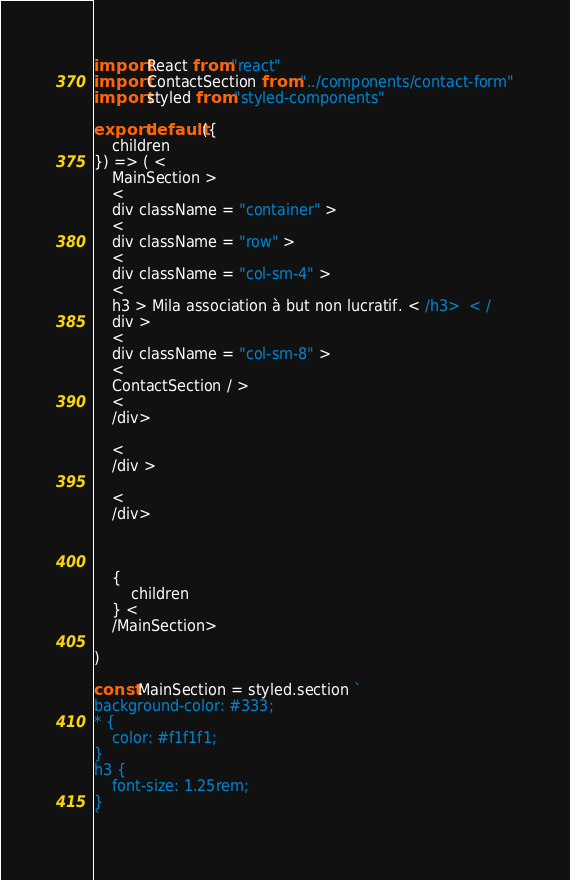<code> <loc_0><loc_0><loc_500><loc_500><_JavaScript_>import React from "react"
import ContactSection from "../components/contact-form"
import styled from "styled-components"

export default ({
    children
}) => ( <
    MainSection >
    <
    div className = "container" >
    <
    div className = "row" >
    <
    div className = "col-sm-4" >
    <
    h3 > Mila association à but non lucratif. < /h3>  < /
    div >
    <
    div className = "col-sm-8" >
    <
    ContactSection / >
    <
    /div>

    <
    /div > 

    <
    /div>



    {
        children
    } <
    /MainSection>

)

const MainSection = styled.section `
background-color: #333;
* {
    color: #f1f1f1;
}
h3 {
    font-size: 1.25rem;
}
`</code> 